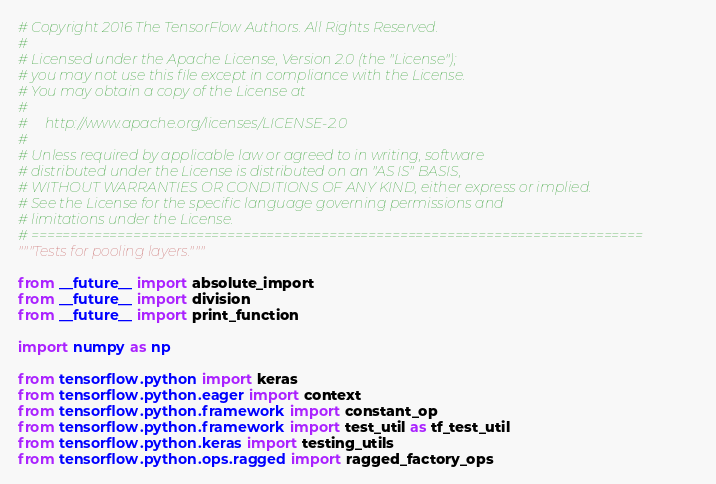<code> <loc_0><loc_0><loc_500><loc_500><_Python_># Copyright 2016 The TensorFlow Authors. All Rights Reserved.
#
# Licensed under the Apache License, Version 2.0 (the "License");
# you may not use this file except in compliance with the License.
# You may obtain a copy of the License at
#
#     http://www.apache.org/licenses/LICENSE-2.0
#
# Unless required by applicable law or agreed to in writing, software
# distributed under the License is distributed on an "AS IS" BASIS,
# WITHOUT WARRANTIES OR CONDITIONS OF ANY KIND, either express or implied.
# See the License for the specific language governing permissions and
# limitations under the License.
# ==============================================================================
"""Tests for pooling layers."""

from __future__ import absolute_import
from __future__ import division
from __future__ import print_function

import numpy as np

from tensorflow.python import keras
from tensorflow.python.eager import context
from tensorflow.python.framework import constant_op
from tensorflow.python.framework import test_util as tf_test_util
from tensorflow.python.keras import testing_utils
from tensorflow.python.ops.ragged import ragged_factory_ops</code> 